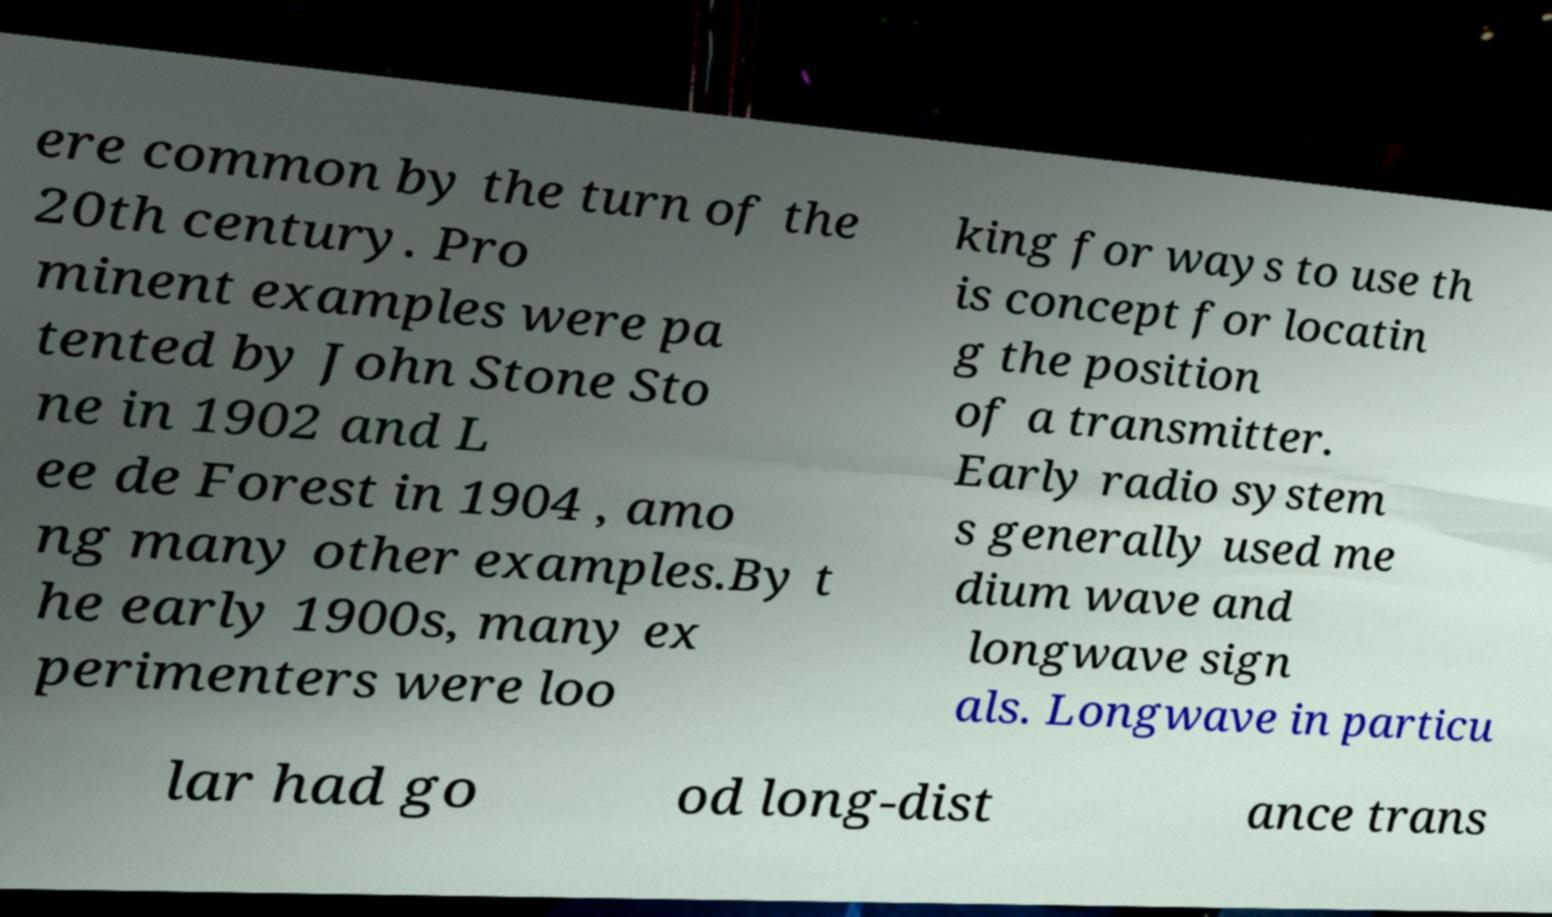For documentation purposes, I need the text within this image transcribed. Could you provide that? ere common by the turn of the 20th century. Pro minent examples were pa tented by John Stone Sto ne in 1902 and L ee de Forest in 1904 , amo ng many other examples.By t he early 1900s, many ex perimenters were loo king for ways to use th is concept for locatin g the position of a transmitter. Early radio system s generally used me dium wave and longwave sign als. Longwave in particu lar had go od long-dist ance trans 